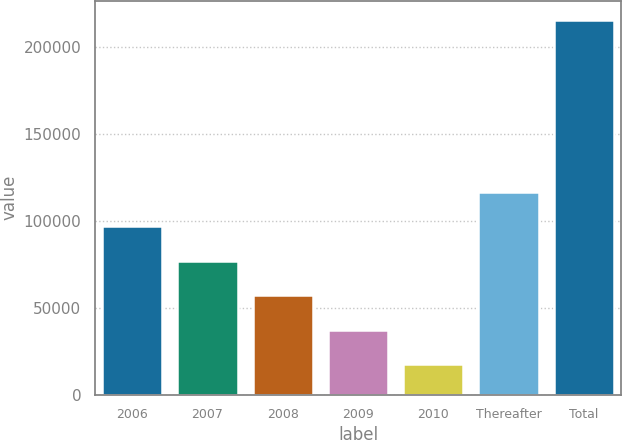Convert chart. <chart><loc_0><loc_0><loc_500><loc_500><bar_chart><fcel>2006<fcel>2007<fcel>2008<fcel>2009<fcel>2010<fcel>Thereafter<fcel>Total<nl><fcel>96730.2<fcel>76938.9<fcel>57147.6<fcel>37356.3<fcel>17565<fcel>116522<fcel>215478<nl></chart> 